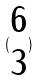Convert formula to latex. <formula><loc_0><loc_0><loc_500><loc_500>( \begin{matrix} 6 \\ 3 \end{matrix} )</formula> 